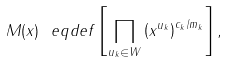<formula> <loc_0><loc_0><loc_500><loc_500>M ( x ) \ e q d e f \left [ \prod _ { u _ { k } \in W } \left ( x ^ { u _ { k } } \right ) ^ { c _ { k } / m _ { k } } \right ] ,</formula> 